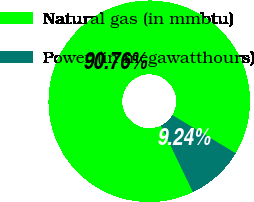Convert chart to OTSL. <chart><loc_0><loc_0><loc_500><loc_500><pie_chart><fcel>Natural gas (in mmbtu)<fcel>Power (in megawatthours)<nl><fcel>90.76%<fcel>9.24%<nl></chart> 